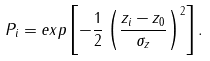<formula> <loc_0><loc_0><loc_500><loc_500>P _ { i } = e x p \left [ - \frac { 1 } { 2 } \left ( \frac { z _ { i } - z _ { 0 } } { \sigma _ { z } } \right ) ^ { 2 } \right ] .</formula> 